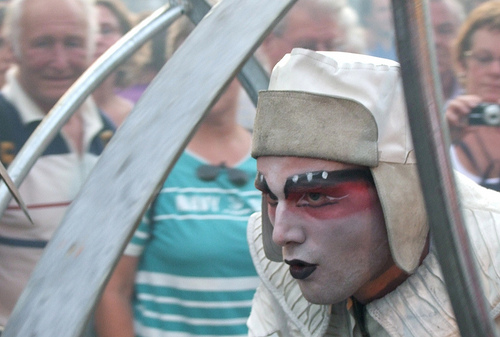<image>
Is there a sunglasses in front of the camera? No. The sunglasses is not in front of the camera. The spatial positioning shows a different relationship between these objects. 